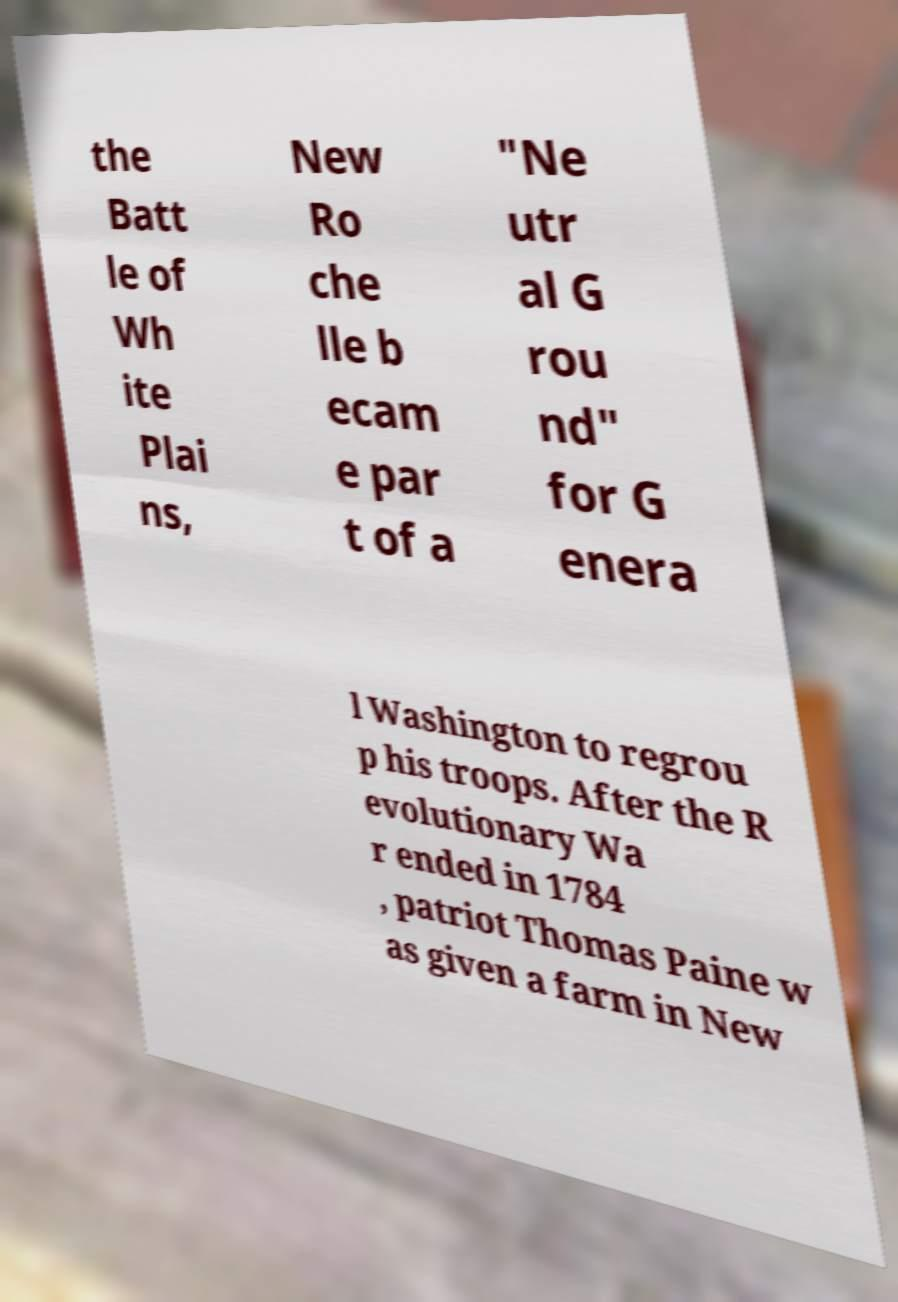There's text embedded in this image that I need extracted. Can you transcribe it verbatim? the Batt le of Wh ite Plai ns, New Ro che lle b ecam e par t of a "Ne utr al G rou nd" for G enera l Washington to regrou p his troops. After the R evolutionary Wa r ended in 1784 , patriot Thomas Paine w as given a farm in New 